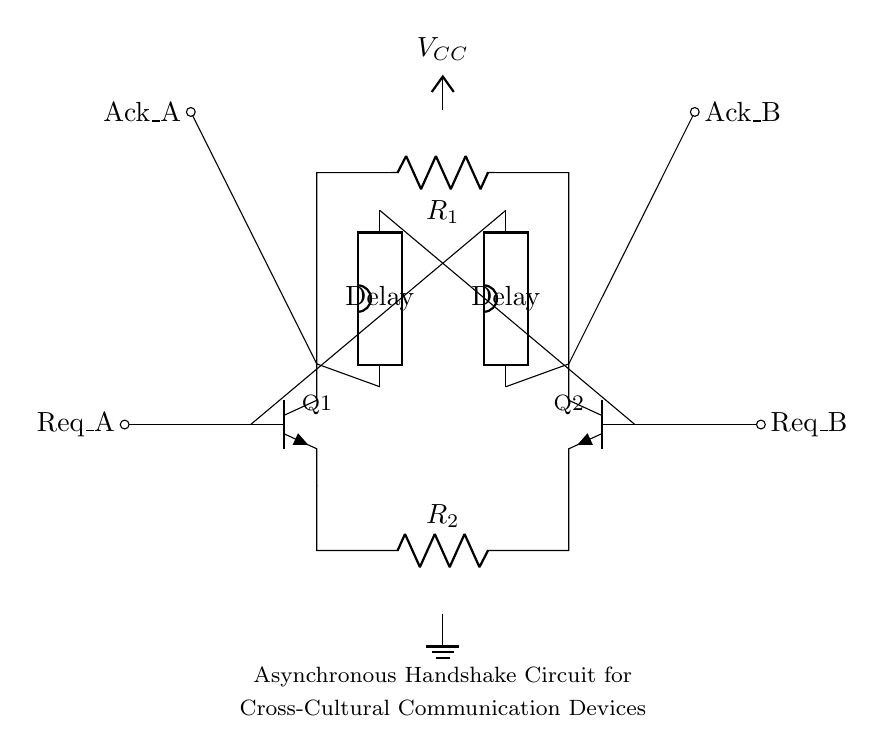What are the main components of the circuit? The main components are two transistors (Q1 and Q2), two resistors (R1 and R2), and two delay elements (D1 and D2).
Answer: Q1, Q2, R1, R2, D1, D2 What is the purpose of the delay elements in this circuit? The delay elements are used to synchronize the handshaking process, allowing for a controlled response time between the two communication devices.
Answer: Synchronization What are the input signals of the circuit? The input signals are Req_A and Req_B, which are the request signals from the two communication devices.
Answer: Req_A, Req_B How many resistors are present in the circuit? There are two resistors in the circuit, labeled as R1 and R2.
Answer: 2 Which component is connected to the positive voltage supply? The component connected to the positive voltage supply (V_CC) is the collector of Q1, as indicated in the diagram.
Answer: Q1 What is the relationship between the output signals Ack_A and Ack_B? The output signals Ack_A and Ack_B are acknowledgment signals sent back to the corresponding request signals Req_A and Req_B, forming a handshaking mechanism.
Answer: Acknowledgment How do the transistors interact in the circuit? The transistors Q1 and Q2 interact to control the flow of signals based on the inputs from their respective request pins, facilitating asynchronous communication.
Answer: Control flow 